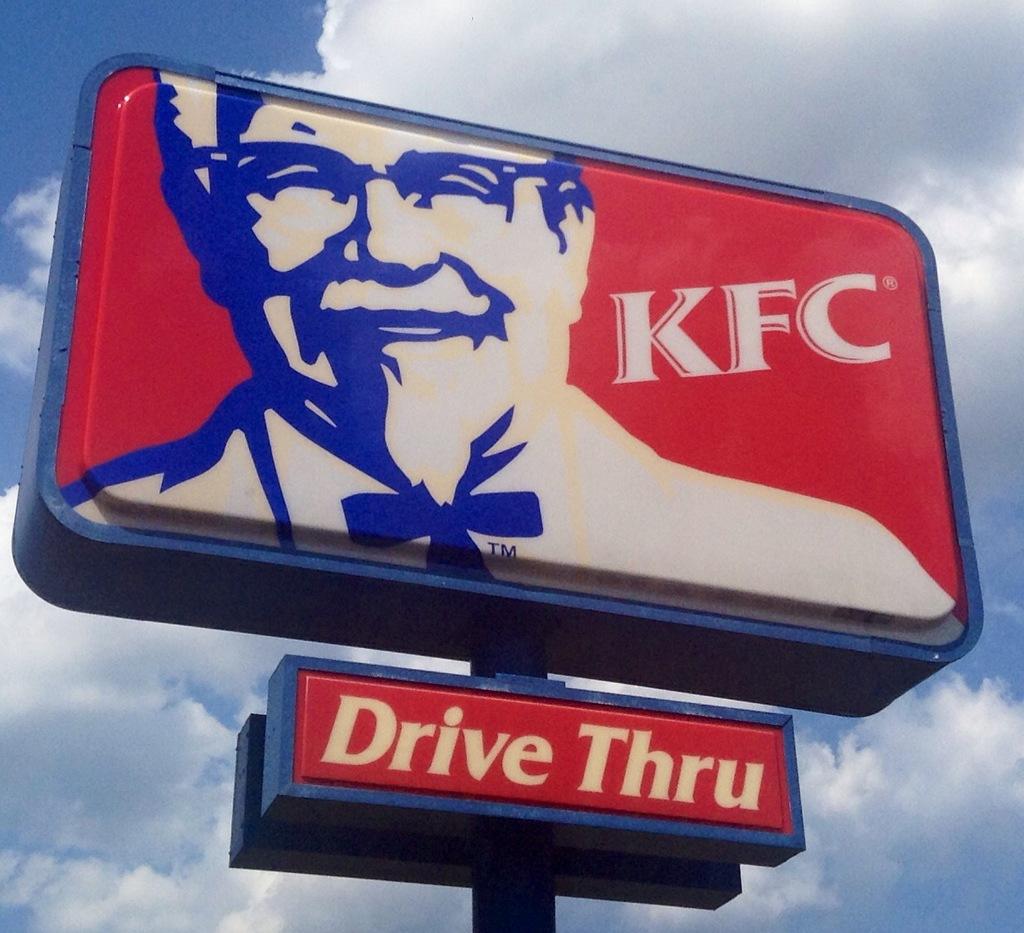What does this kfc have?
Give a very brief answer. Drive thru. 